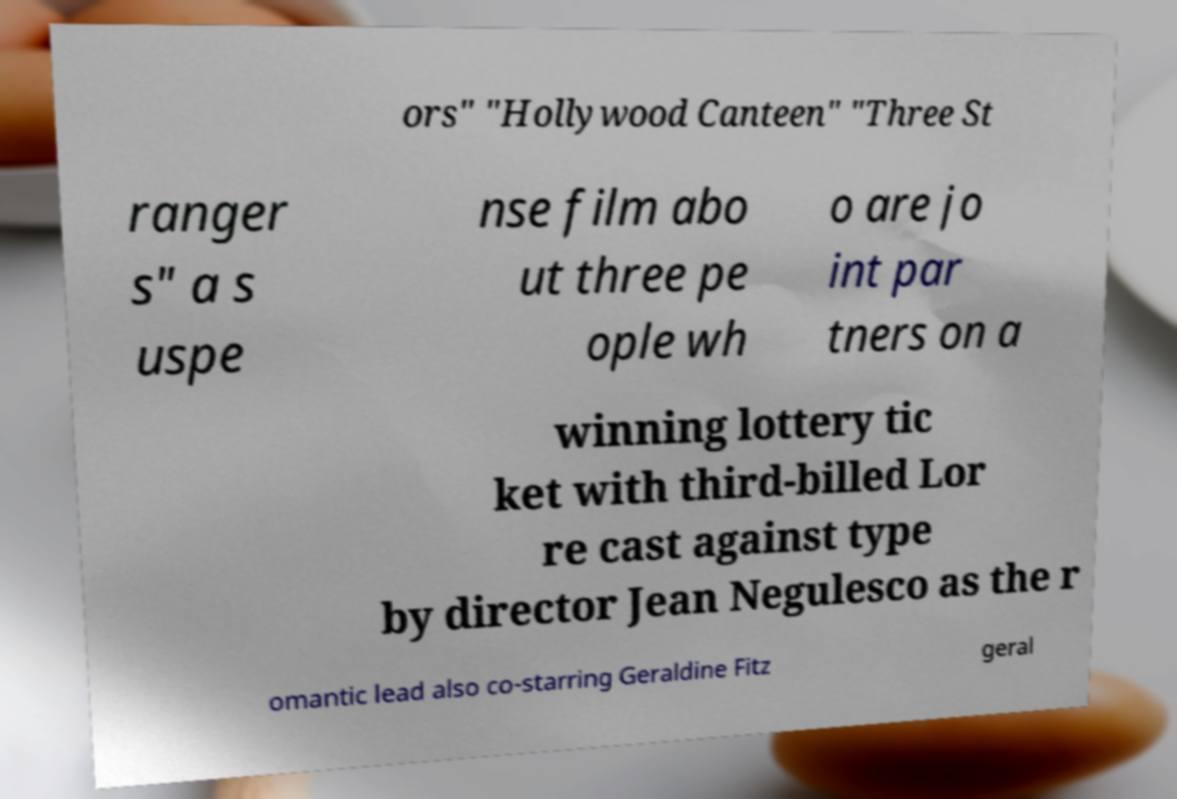Could you extract and type out the text from this image? ors" "Hollywood Canteen" "Three St ranger s" a s uspe nse film abo ut three pe ople wh o are jo int par tners on a winning lottery tic ket with third-billed Lor re cast against type by director Jean Negulesco as the r omantic lead also co-starring Geraldine Fitz geral 